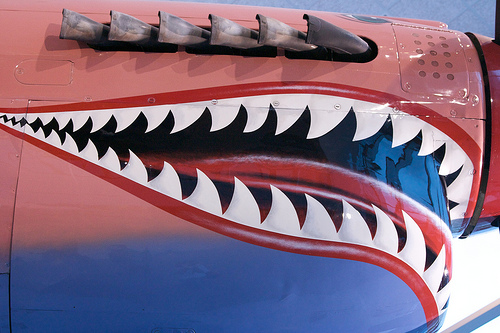<image>
Is there a teeth on the plane? Yes. Looking at the image, I can see the teeth is positioned on top of the plane, with the plane providing support. 